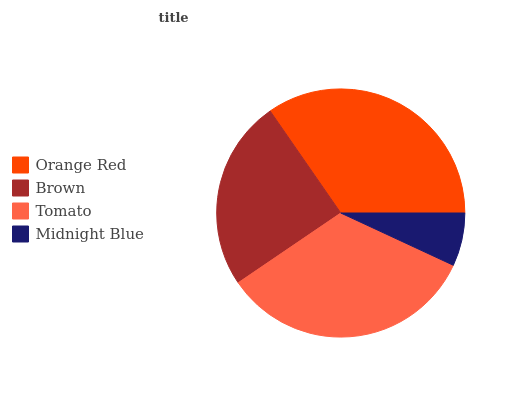Is Midnight Blue the minimum?
Answer yes or no. Yes. Is Orange Red the maximum?
Answer yes or no. Yes. Is Brown the minimum?
Answer yes or no. No. Is Brown the maximum?
Answer yes or no. No. Is Orange Red greater than Brown?
Answer yes or no. Yes. Is Brown less than Orange Red?
Answer yes or no. Yes. Is Brown greater than Orange Red?
Answer yes or no. No. Is Orange Red less than Brown?
Answer yes or no. No. Is Tomato the high median?
Answer yes or no. Yes. Is Brown the low median?
Answer yes or no. Yes. Is Midnight Blue the high median?
Answer yes or no. No. Is Midnight Blue the low median?
Answer yes or no. No. 